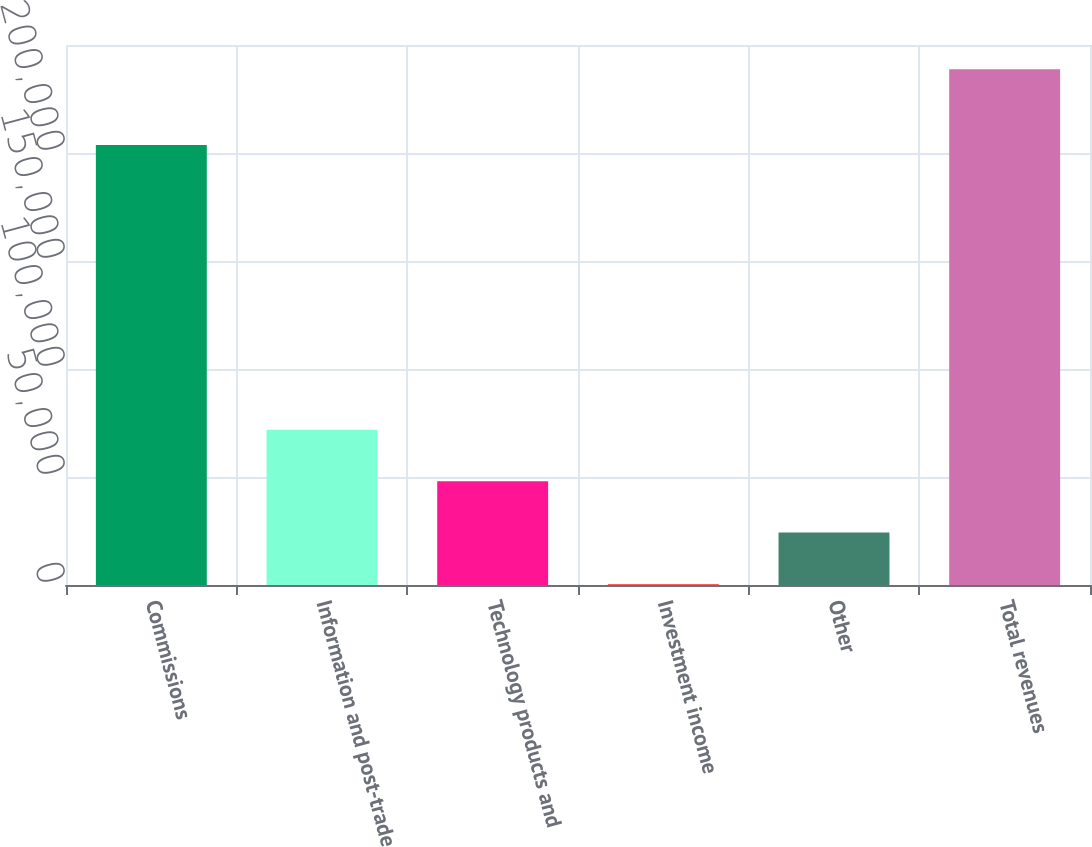Convert chart to OTSL. <chart><loc_0><loc_0><loc_500><loc_500><bar_chart><fcel>Commissions<fcel>Information and post-trade<fcel>Technology products and<fcel>Investment income<fcel>Other<fcel>Total revenues<nl><fcel>203652<fcel>71913.9<fcel>48082.6<fcel>420<fcel>24251.3<fcel>238733<nl></chart> 